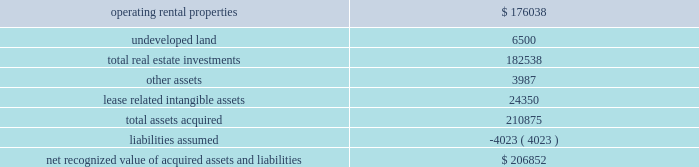57 annual report 2009 duke realty corporation | | use of estimates the preparation of the financial statements requires management to make a number of estimates and assumptions that affect the reported amount of assets and liabilities and the disclosure of contingent assets and liabilities at the date of the financial statements and the reported amounts of revenues and expenses during the period .
The most significant estimates , as discussed within our summary of significant accounting policies , pertain to the critical assumptions utilized in testing real estate assets for impairment as well as in estimating the fair value of real estate assets when an impairment event has taken place .
Actual results could differ from those estimates .
( 3 ) significant acquisitions and dispositions consolidation of retail joint ventures through march 31 , 2009 , we were a member in two retail real estate joint ventures with a retail developer .
Both entities were jointly controlled by us and our partner , through equal voting interests , and were accounted for as unconsolidated subsidiaries under the equity method .
As of april 1 , 2009 , we had made combined equity contributions of $ 37.9 million to the two entities and we also had combined outstanding principal and accrued interest of $ 173.0 million on advances to the two entities .
We advanced $ 2.0 million to the two entities , who then distributed the $ 2.0 million to our partner in exchange for the redemption of our partner 2019s membership interests , effective april 1 , 2009 , at which time we obtained 100% ( 100 % ) control of the voting interests of both entities .
We entered these transactions to gain control of these two entities because it will allow us to operate or dispose of the entities in a manner that best serves our capital needs .
In conjunction with the redemption of our partner 2019s membership interests , we entered a profits interest agreement that entitles our former partner to additional payments should the combined sale of the two acquired entities , as well as the sale of another retail real estate joint venture that we and our partner still jointly control , result in an aggregate profit .
Aggregate profit on the sale of these three projects will be calculated by using a formula defined in the profits interest agreement .
We have estimated that the fair value of the potential additional payment to our partner is insignificant .
A summary of the fair value of amounts recognized for each major class of assets and liabilities acquired is as follows ( in thousands ) : .
The fair values recognized from the real estate and related assets acquired were primarily determined using the income approach .
The most significant assumptions in the fair value estimates were the discount rates and the exit capitalization rates .
The estimates of fair value were determined to have primarily relied upon level 3 inputs. .
Of the total real estate investments what was the percent of operating rental properties? 
Rationale: 96.4% of the total real estate investments was operating rental properties
Computations: (176038 / 182538)
Answer: 0.96439. 